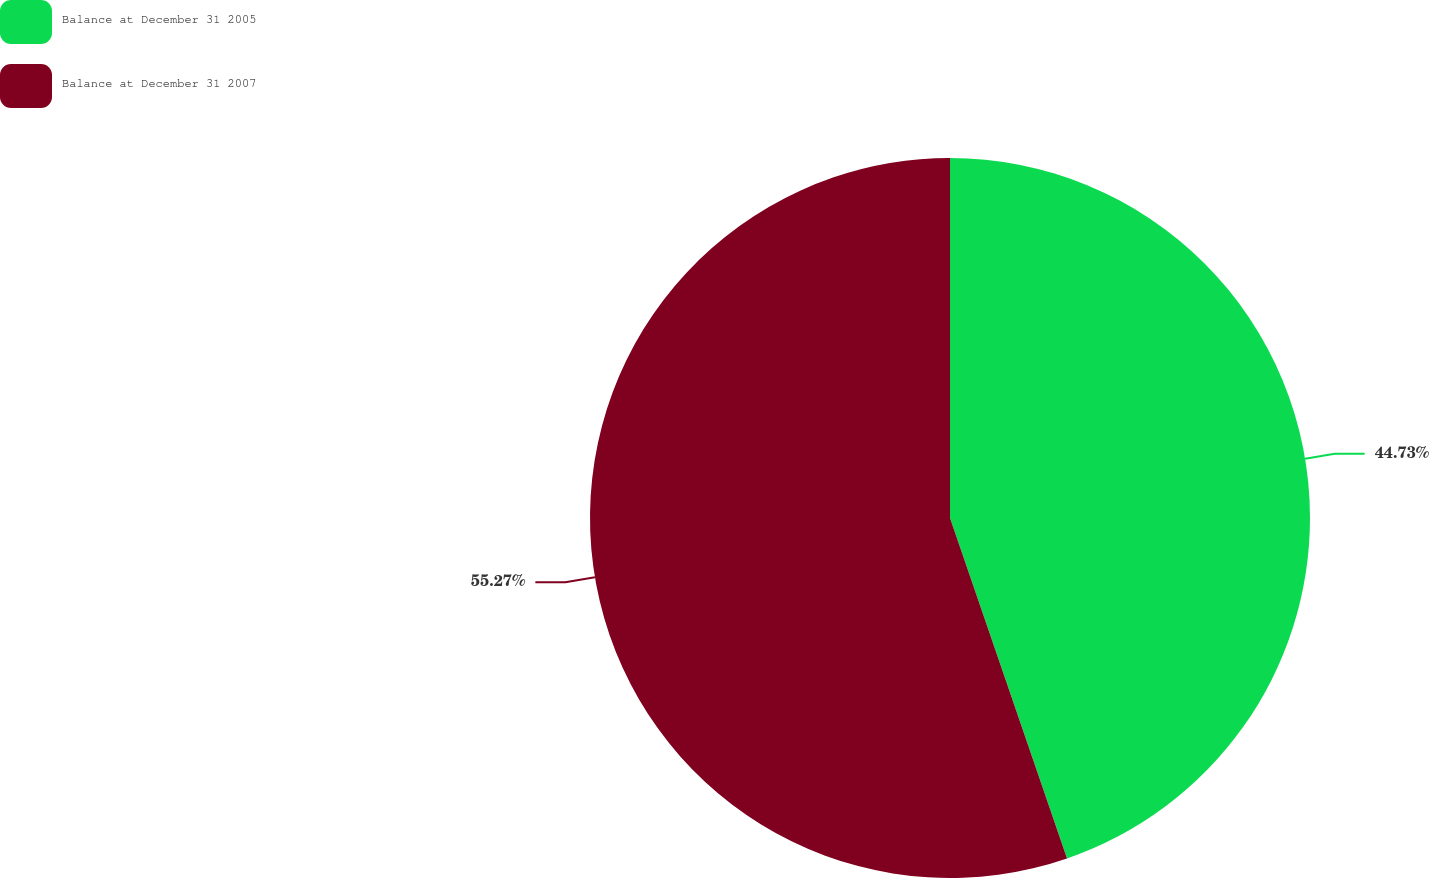Convert chart. <chart><loc_0><loc_0><loc_500><loc_500><pie_chart><fcel>Balance at December 31 2005<fcel>Balance at December 31 2007<nl><fcel>44.73%<fcel>55.27%<nl></chart> 